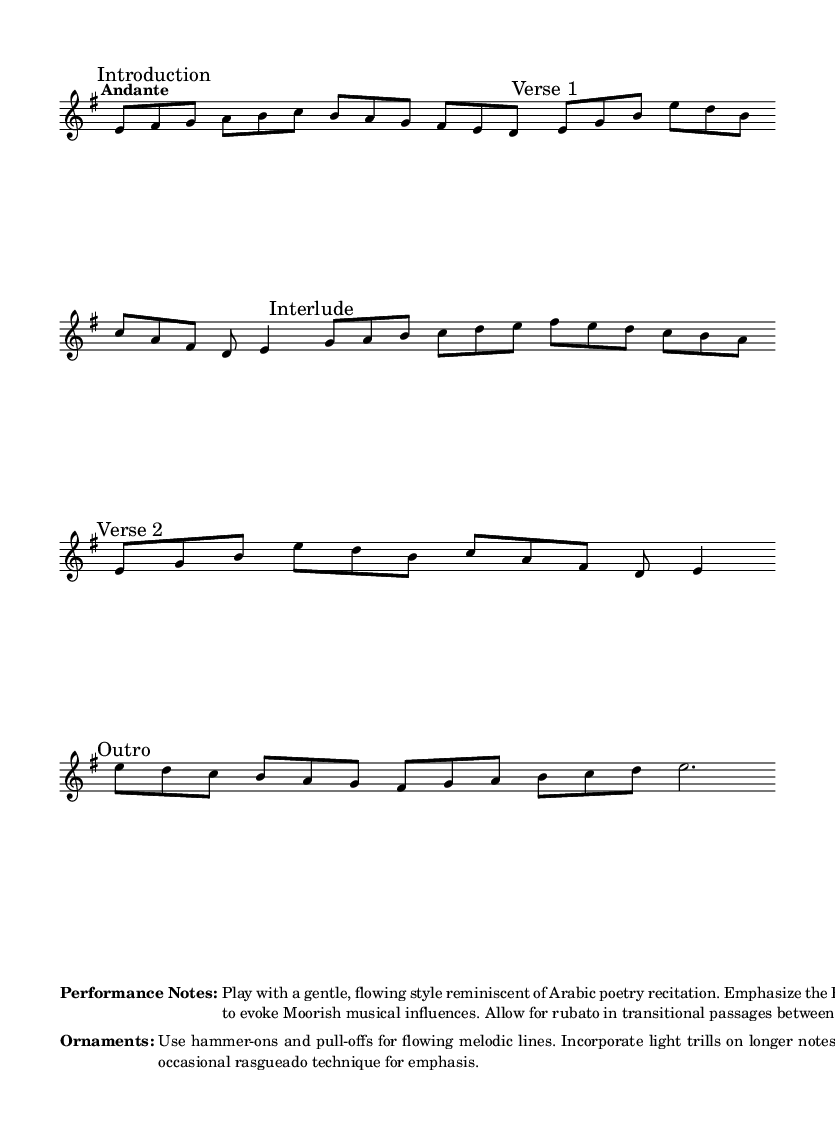What is the key signature of this music? The key signature is E minor, which has one sharp (F#). This is inferred from the "key e" notation at the beginning of the score.
Answer: E minor What is the time signature of this music? The time signature is 6/8, as indicated by the "time 6/8" at the beginning of the score. This means there are six eighth notes in each measure.
Answer: 6/8 What is the tempo marking for this piece? The tempo marking is "Andante," which means a moderate pace, typically around 76-108 beats per minute. This is found in the tempo notation right after the time signature.
Answer: Andante How many verses are in the piece? There are two verses in the piece, as noted by the phrases "Verse 1" and "Verse 2" marking different sections in the score.
Answer: 2 What performance style is suggested for this piece? The performance style suggested is "gentle, flowing," with emphasis on the Phrygian mode to evoke the feeling of Arabic poetry. This is indicated in the performance notes section.
Answer: Gentle, flowing Which ornamentation technique is recommended for melodic lines? Hammer-ons and pull-offs are recommended for the melodic lines. This is detailed in the ornaments section of the score.
Answer: Hammer-ons and pull-offs What is the duration of the final note in the outro? The final note in the outro is a dotted half note, which signifies it should be held for three beats, as indicated in the last part of the score.
Answer: Dotted half note 